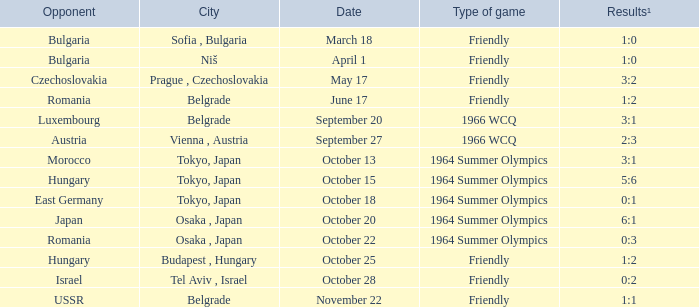What was the opponent on october 28? Israel. 